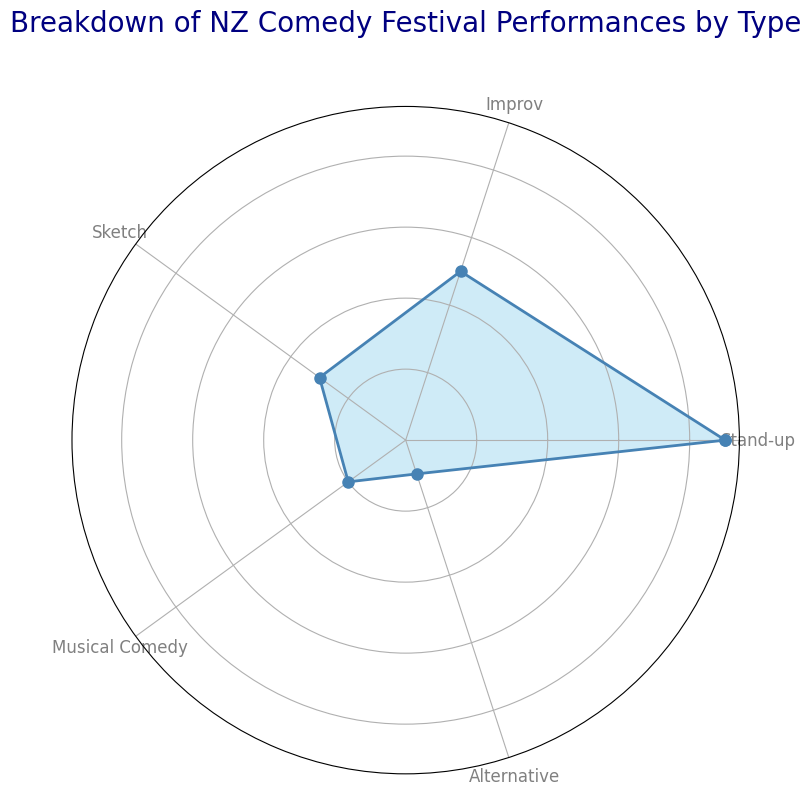What is the type of comedy with the highest percentage? The rose chart shows that Stand-up occupies the largest section with 45%.
Answer: Stand-up What is the combined percentage of Improv and Sketch comedy? Looking at the chart, Improv has 25% and Sketch has 15%, adding these gives 25% + 15% = 40%.
Answer: 40% Which type of comedy has the lowest percentage? The smallest section of the rose chart represents Alternative comedy with 5%.
Answer: Alternative How much more percentage does Stand-up have than Musical Comedy? Stand-up is at 45%, while Musical Comedy is at 10%, so the difference is 45% - 10% = 35%.
Answer: 35% Rank the types of comedy from highest to lowest percentage. Observing the chart from the largest to smallest sections: Stand-up (45%), Improv (25%), Sketch (15%), Musical Comedy (10%), and Alternative (5%).
Answer: Stand-up, Improv, Sketch, Musical Comedy, Alternative Is the percentage of Improv comedy greater than the combined percentage of Musical Comedy and Alternative? Improv comedy is at 25%, while Musical Comedy and Alternative combined are at 10% + 5% = 15%. 25% is greater than 15%.
Answer: Yes What is the percentage difference between Sketch and Alternative comedy? Sketch is at 15% and Alternative is at 5%, so the difference is 15% - 5% = 10%.
Answer: 10% How many types of comedy have a percentage greater than 10%? From the chart: Stand-up (45%), Improv (25%), and Sketch (15%) are all greater than 10%. There are 3 types.
Answer: 3 Which types of comedy make up less than one-third of the total percentage each? Sketch (15%), Musical Comedy (10%), and Alternative (5%) each occupy less than 33.33%.
Answer: Sketch, Musical Comedy, Alternative What is the visual difference between the lines representing Stand-up and Alternative comedy? The section for Stand-up is much larger, with markers more spread out, while Alternative's section is narrow with markers closer together.
Answer: Stand-up is larger 